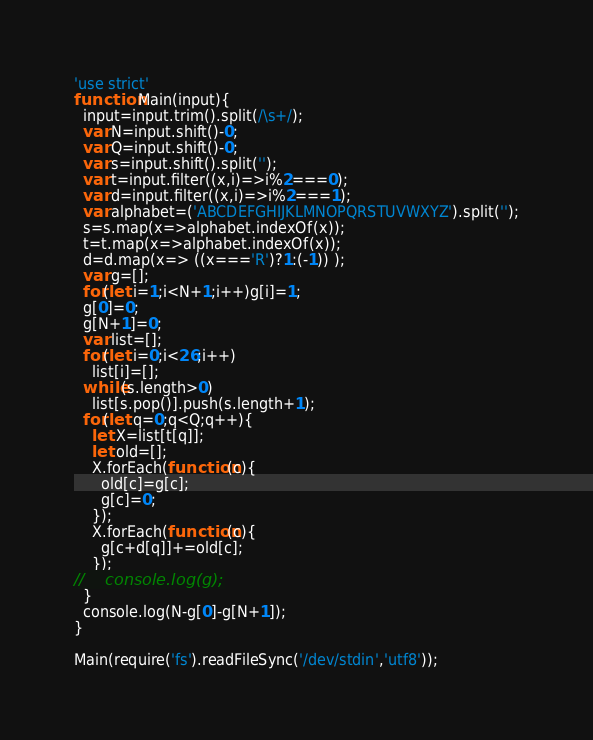<code> <loc_0><loc_0><loc_500><loc_500><_JavaScript_>'use strict'
function Main(input){
  input=input.trim().split(/\s+/);
  var N=input.shift()-0;
  var Q=input.shift()-0;
  var s=input.shift().split('');
  var t=input.filter((x,i)=>i%2===0);
  var d=input.filter((x,i)=>i%2===1);
  var alphabet=('ABCDEFGHIJKLMNOPQRSTUVWXYZ').split('');
  s=s.map(x=>alphabet.indexOf(x));
  t=t.map(x=>alphabet.indexOf(x));
  d=d.map(x=> ((x==='R')?1:(-1)) );
  var g=[];
  for(let i=1;i<N+1;i++)g[i]=1;
  g[0]=0;
  g[N+1]=0;
  var list=[];
  for(let i=0;i<26;i++)
    list[i]=[];
  while(s.length>0)
    list[s.pop()].push(s.length+1);
  for(let q=0;q<Q;q++){
    let X=list[t[q]];
    let old=[];
    X.forEach(function(c){
      old[c]=g[c];
      g[c]=0;
    });
    X.forEach(function(c){
      g[c+d[q]]+=old[c];
    });
//    console.log(g);
  }
  console.log(N-g[0]-g[N+1]);
}

Main(require('fs').readFileSync('/dev/stdin','utf8'));</code> 